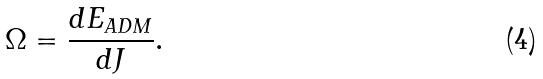Convert formula to latex. <formula><loc_0><loc_0><loc_500><loc_500>\Omega = \frac { d E _ { A D M } } { d J } .</formula> 